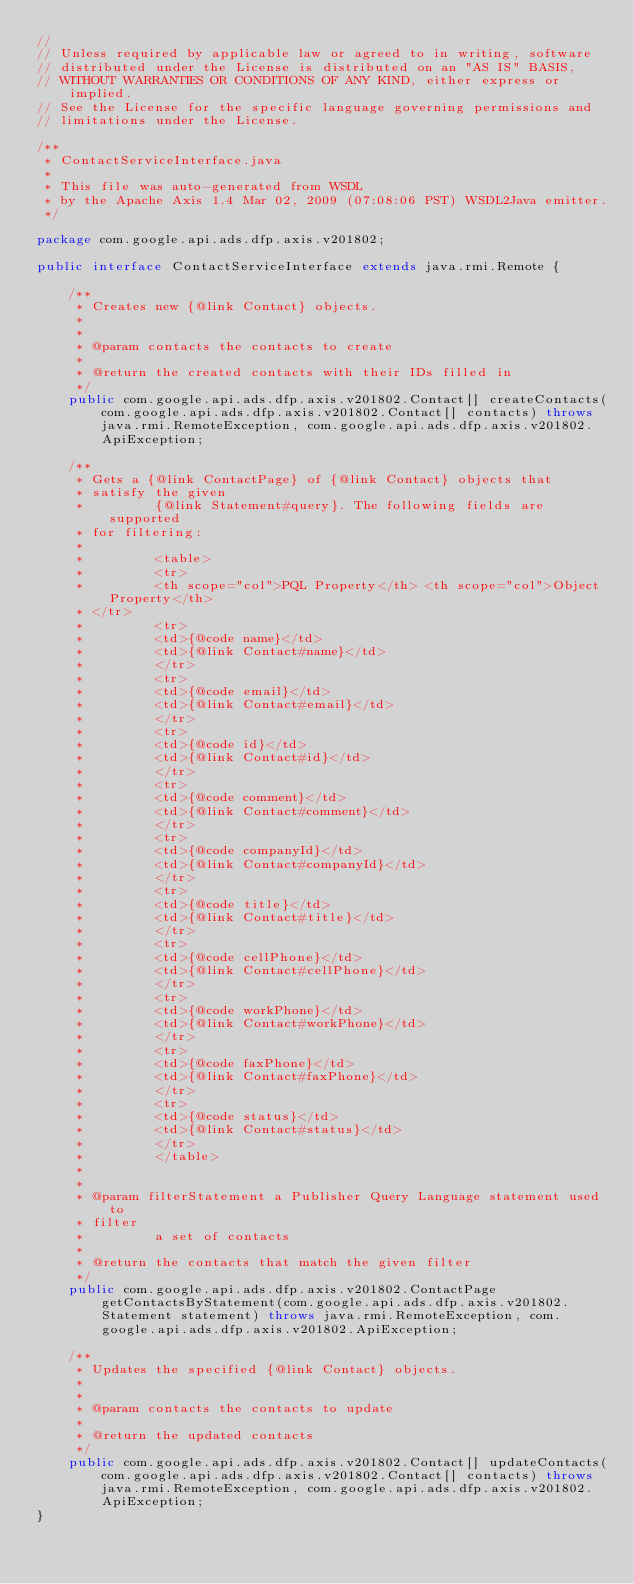<code> <loc_0><loc_0><loc_500><loc_500><_Java_>//
// Unless required by applicable law or agreed to in writing, software
// distributed under the License is distributed on an "AS IS" BASIS,
// WITHOUT WARRANTIES OR CONDITIONS OF ANY KIND, either express or implied.
// See the License for the specific language governing permissions and
// limitations under the License.

/**
 * ContactServiceInterface.java
 *
 * This file was auto-generated from WSDL
 * by the Apache Axis 1.4 Mar 02, 2009 (07:08:06 PST) WSDL2Java emitter.
 */

package com.google.api.ads.dfp.axis.v201802;

public interface ContactServiceInterface extends java.rmi.Remote {

    /**
     * Creates new {@link Contact} objects.
     *         
     *         
     * @param contacts the contacts to create
     *         
     * @return the created contacts with their IDs filled in
     */
    public com.google.api.ads.dfp.axis.v201802.Contact[] createContacts(com.google.api.ads.dfp.axis.v201802.Contact[] contacts) throws java.rmi.RemoteException, com.google.api.ads.dfp.axis.v201802.ApiException;

    /**
     * Gets a {@link ContactPage} of {@link Contact} objects that
     * satisfy the given
     *         {@link Statement#query}. The following fields are supported
     * for filtering:
     *         
     *         <table>
     *         <tr>
     *         <th scope="col">PQL Property</th> <th scope="col">Object Property</th>
     * </tr>
     *         <tr>
     *         <td>{@code name}</td>
     *         <td>{@link Contact#name}</td>
     *         </tr>
     *         <tr>
     *         <td>{@code email}</td>
     *         <td>{@link Contact#email}</td>
     *         </tr>
     *         <tr>
     *         <td>{@code id}</td>
     *         <td>{@link Contact#id}</td>
     *         </tr>
     *         <tr>
     *         <td>{@code comment}</td>
     *         <td>{@link Contact#comment}</td>
     *         </tr>
     *         <tr>
     *         <td>{@code companyId}</td>
     *         <td>{@link Contact#companyId}</td>
     *         </tr>
     *         <tr>
     *         <td>{@code title}</td>
     *         <td>{@link Contact#title}</td>
     *         </tr>
     *         <tr>
     *         <td>{@code cellPhone}</td>
     *         <td>{@link Contact#cellPhone}</td>
     *         </tr>
     *         <tr>
     *         <td>{@code workPhone}</td>
     *         <td>{@link Contact#workPhone}</td>
     *         </tr>
     *         <tr>
     *         <td>{@code faxPhone}</td>
     *         <td>{@link Contact#faxPhone}</td>
     *         </tr>
     *         <tr>
     *         <td>{@code status}</td>
     *         <td>{@link Contact#status}</td>
     *         </tr>
     *         </table>
     *         
     *         
     * @param filterStatement a Publisher Query Language statement used to
     * filter
     *         a set of contacts
     *         
     * @return the contacts that match the given filter
     */
    public com.google.api.ads.dfp.axis.v201802.ContactPage getContactsByStatement(com.google.api.ads.dfp.axis.v201802.Statement statement) throws java.rmi.RemoteException, com.google.api.ads.dfp.axis.v201802.ApiException;

    /**
     * Updates the specified {@link Contact} objects.
     *         
     *         
     * @param contacts the contacts to update
     *         
     * @return the updated contacts
     */
    public com.google.api.ads.dfp.axis.v201802.Contact[] updateContacts(com.google.api.ads.dfp.axis.v201802.Contact[] contacts) throws java.rmi.RemoteException, com.google.api.ads.dfp.axis.v201802.ApiException;
}
</code> 